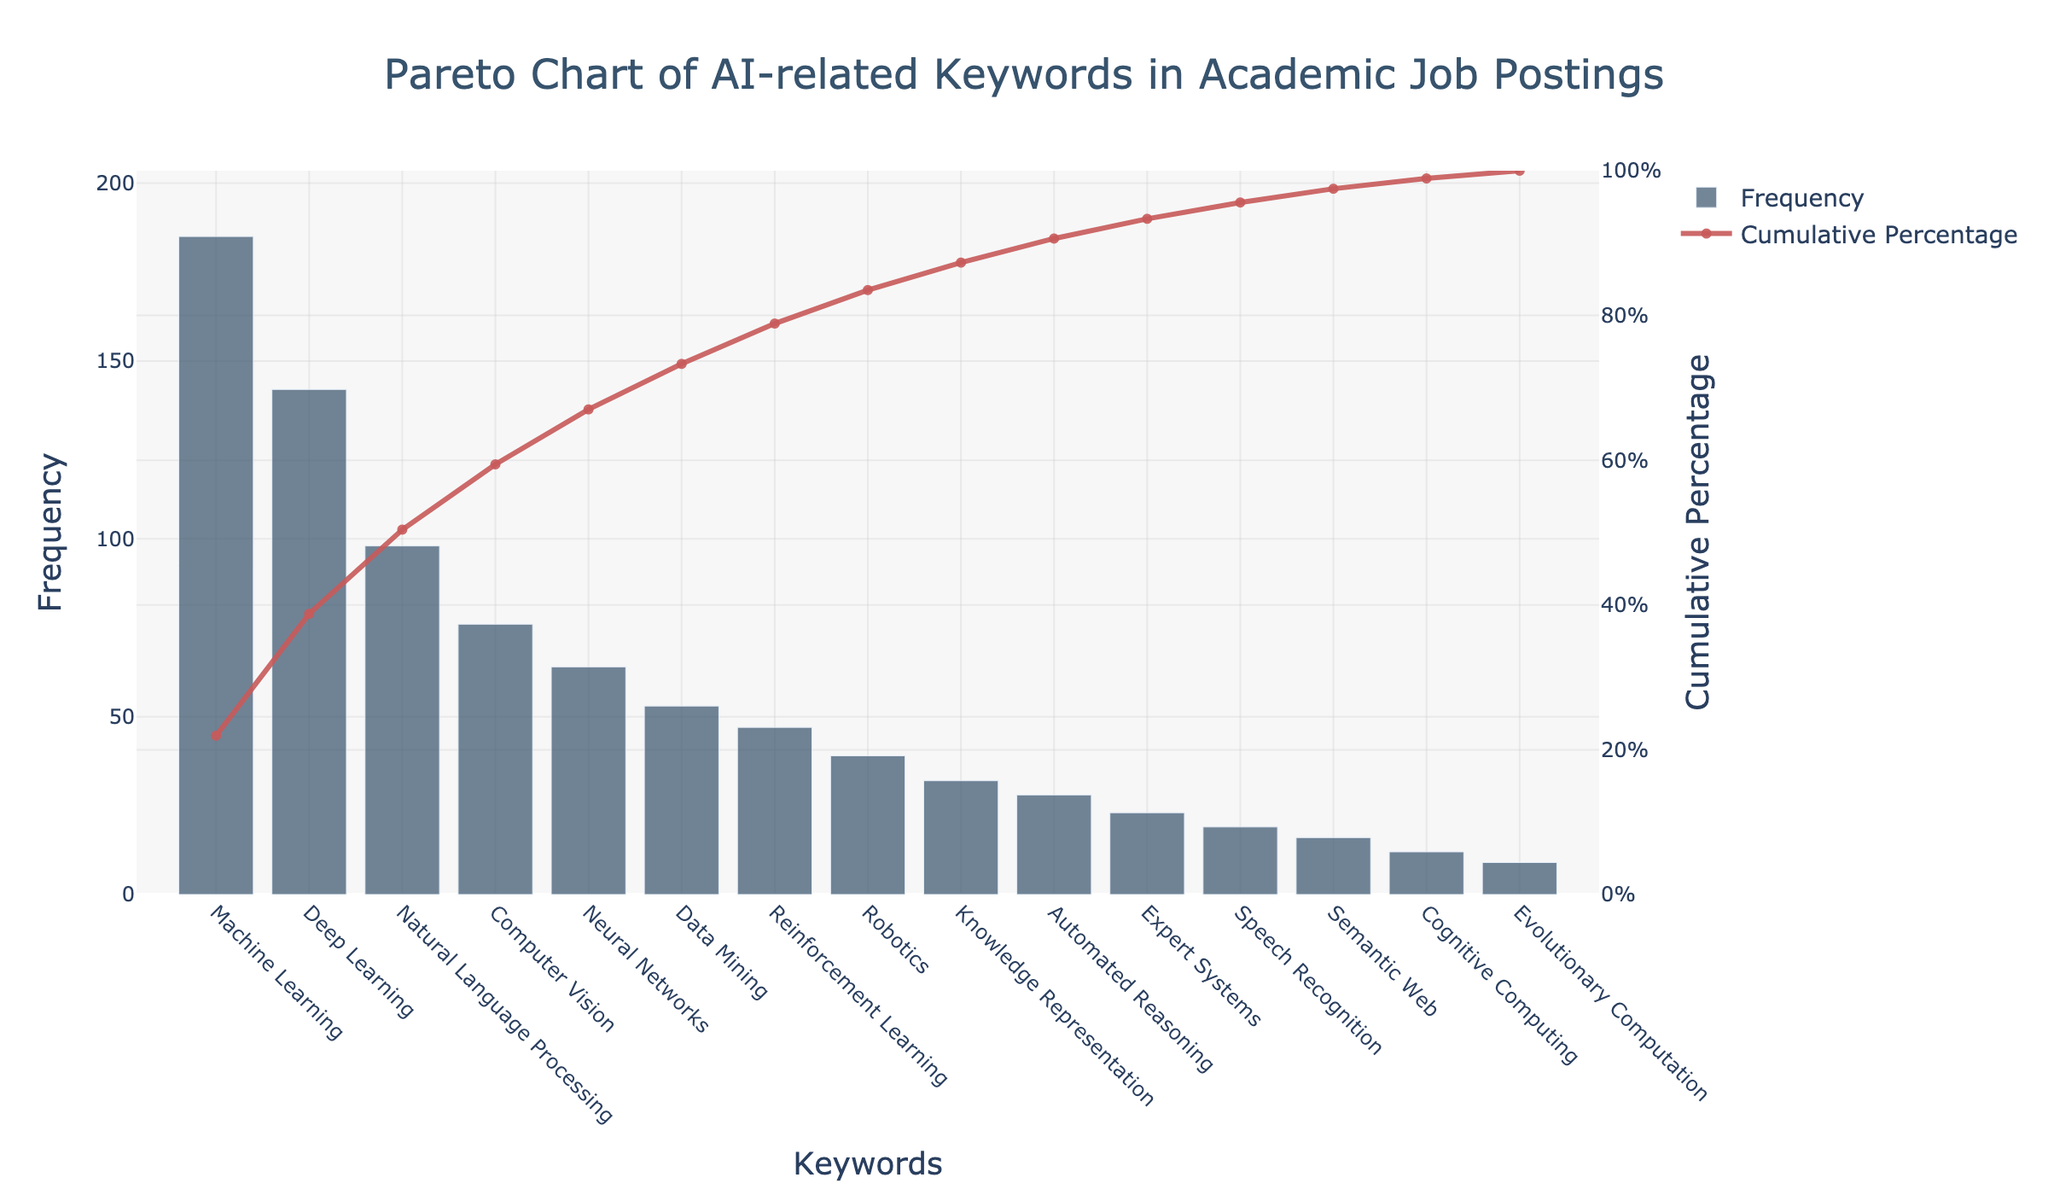what is the highest frequency keyword? The keyword with the highest bar in the chart represents the highest frequency. It’s the first keyword listed on the x-axis.
Answer: Machine Learning What is the cumulative percentage for the keyword 'Natural Language Processing'? Locate 'Natural Language Processing' on the x-axis and then refer to the corresponding point on the cumulative percentage line (y-axis on the right). Read the percentage value corresponding to that point.
Answer: 57.2% Which keyword has a frequency of 39? Find the bar that reaches up to the frequency of 39 on the y-axis and then look at the keyword associated with this bar on the x-axis.
Answer: Robotics Compare the frequencies of 'Deep Learning' and 'Reinforcement Learning'. Locate the bars for both 'Deep Learning' and 'Reinforcement Learning' on the chart. 'Deep Learning' is significantly taller than 'Reinforcement Learning', indicating a much higher frequency. Specifically, 'Deep Learning' has a frequency of 142 and 'Reinforcement Learning' has 47.
Answer: Deep Learning > Reinforcement Learning How many keywords have a cumulative percentage greater than 80%? Identify the point on the cumulative percentage line where it exceeds 80% on the y-axis, then count the number of keywords to the right of this point on the x-axis to see how many keywords are beyond this cumulative percentage.
Answer: 5 Which keywords collectively cover the first 50% of the cumulative percentage? Starting from the left on the x-axis, sum the cumulative percentages until you surpass 50%. The keywords listed before crossing this threshold are the ones that collectively cover the first 50%. These keywords are 'Machine Learning', 'Deep Learning', and 'Natural Language Processing'.
Answer: Machine Learning, Deep Learning, Natural Language Processing What is the total number of keywords shown in the chart? Count the number of distinct keywords listed on the x-axis of the chart.
Answer: 15 Between 'Computer Vision' and 'Neural Networks', which one has a higher frequency and by how much? Compare the heights of the bars for 'Computer Vision' and 'Neural Networks'. Subtract the frequency of 'Neural Networks' (64) from 'Computer Vision' (76).
Answer: Computer Vision by 12 Which keyword appears just before ‘Robotics’ in terms of frequency? Locate 'Robotics' on the x-axis then look at the keyword immediately to its left.
Answer: Reinforcement Learning 